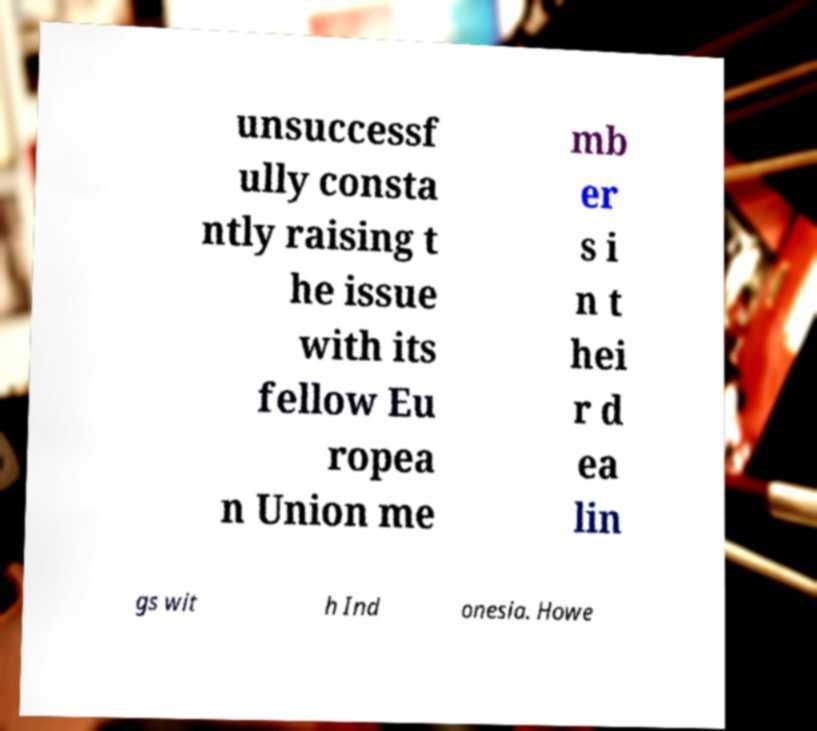There's text embedded in this image that I need extracted. Can you transcribe it verbatim? unsuccessf ully consta ntly raising t he issue with its fellow Eu ropea n Union me mb er s i n t hei r d ea lin gs wit h Ind onesia. Howe 